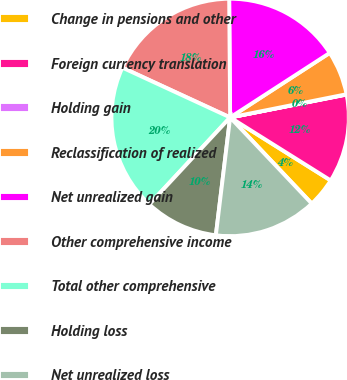<chart> <loc_0><loc_0><loc_500><loc_500><pie_chart><fcel>Change in pensions and other<fcel>Foreign currency translation<fcel>Holding gain<fcel>Reclassification of realized<fcel>Net unrealized gain<fcel>Other comprehensive income<fcel>Total other comprehensive<fcel>Holding loss<fcel>Net unrealized loss<nl><fcel>4.02%<fcel>12.0%<fcel>0.04%<fcel>6.02%<fcel>15.98%<fcel>17.98%<fcel>19.97%<fcel>10.0%<fcel>13.99%<nl></chart> 